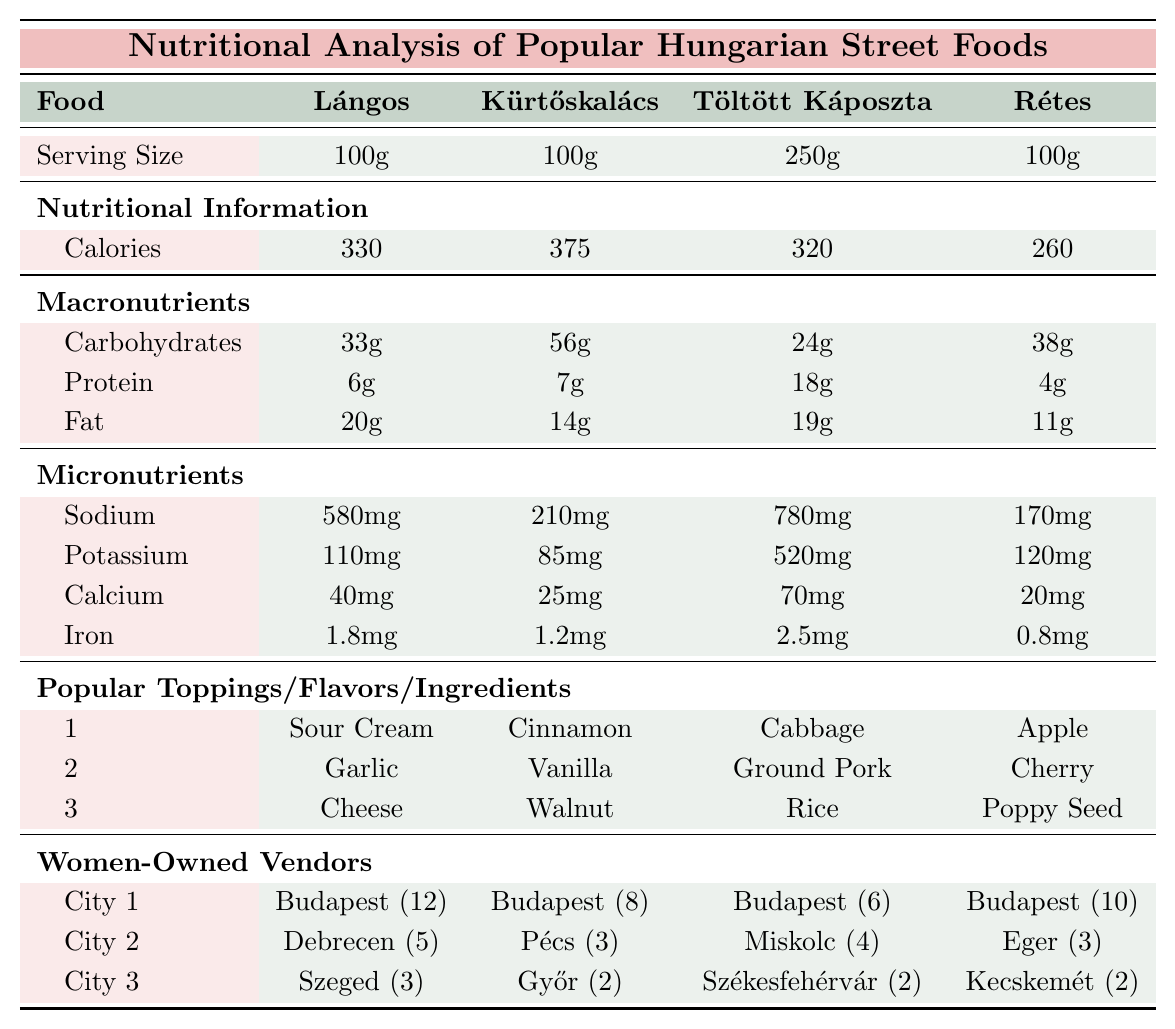What is the serving size of Lángos? The table states the serving size of Lángos is 100g.
Answer: 100g Which food has the highest calories? By examining the calorie content in the table, Kürtőskalács has the highest calories with 375.
Answer: Kürtőskalács What is the total number of women-owned vendors for Töltött Káposzta in Budapest, Miskolc, and Székesfehérvár? Adding the women-owned vendors: 6 (Budapest) + 4 (Miskolc) + 2 (Székesfehérvár) equals 12.
Answer: 12 Is there a higher sodium content in Lángos or Rétes? The sodium content for Lángos is 580mg, and for Rétes it is 170mg. Lángos has the higher sodium content.
Answer: Yes What are the popular toppings for Lángos? The table lists the popular toppings for Lángos as Sour Cream, Garlic, and Cheese.
Answer: Sour Cream, Garlic, Cheese How much total protein do the four foods provide per serving? The total protein is calculated by adding protein from each food: 6g (Lángos) + 7g (Kürtőskalács) + 18g (Töltött Káposzta) + 4g (Rétes) = 35g.
Answer: 35g Which city has the least number of women-owned vendors for Kürtőskalács? The vendors for Kürtőskalács are: Budapest (8), Pécs (3), Győr (2). Győr has the least with 2 vendors.
Answer: Győr What percentage of women-owned vendors for Lángos are in Budapest? There are 12 vendors in Budapest out of a total of 20 (12+5+3). The percentage is (12/20)*100 = 60%.
Answer: 60% What is the fat content difference between Töltött Káposzta and Rétes? Fat content for Töltött Káposzta is 19g, and for Rétes is 11g. The difference is 19g - 11g = 8g.
Answer: 8g How many more women-owned vendors are there for Lángos compared to Kürtőskalács in Budapest? There are 12 vendors for Lángos and 8 for Kürtőskalács in Budapest. The difference is 12 - 8 = 4.
Answer: 4 